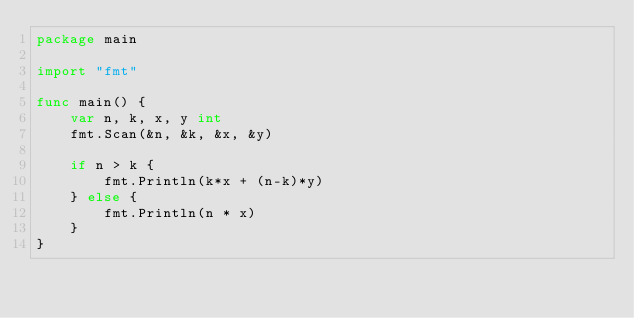<code> <loc_0><loc_0><loc_500><loc_500><_Go_>package main

import "fmt"

func main() {
	var n, k, x, y int
	fmt.Scan(&n, &k, &x, &y)

	if n > k {
		fmt.Println(k*x + (n-k)*y)
	} else {
		fmt.Println(n * x)
	}
}
</code> 